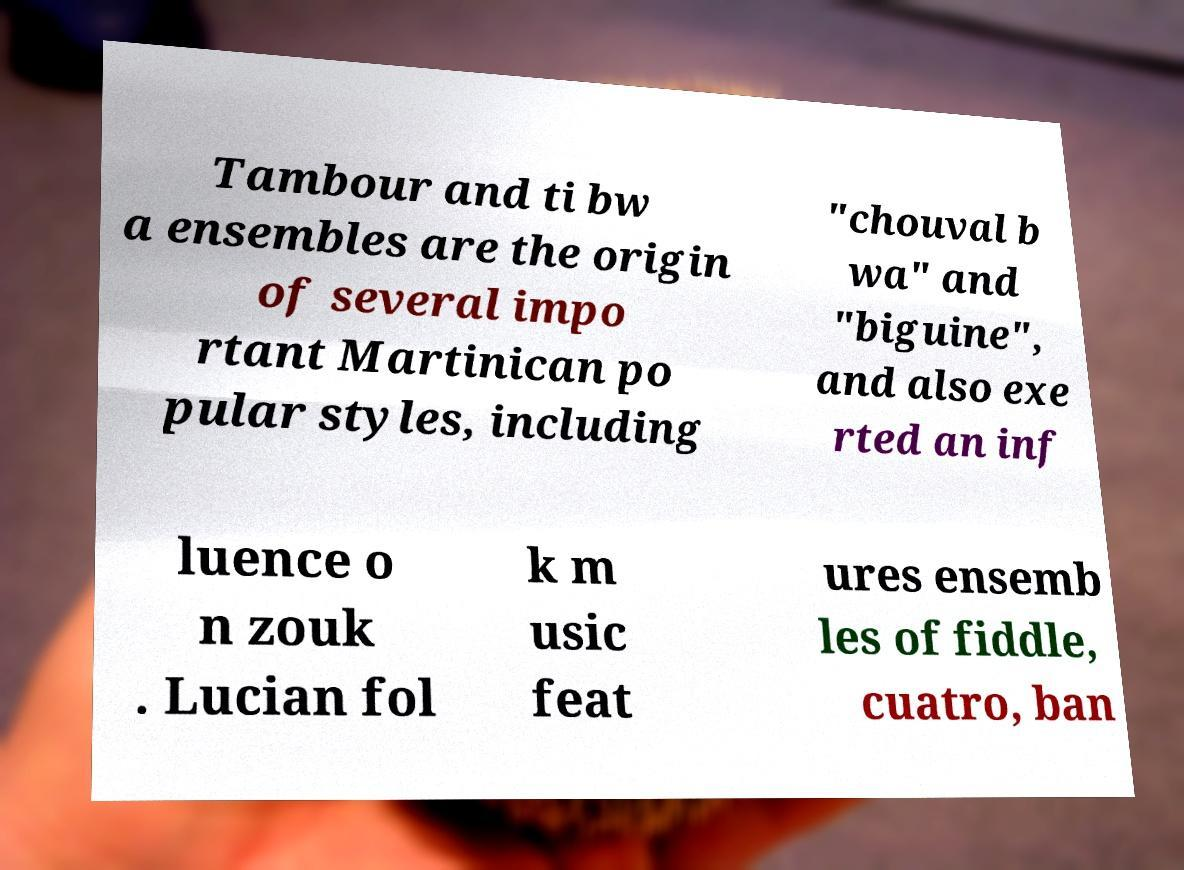Can you accurately transcribe the text from the provided image for me? Tambour and ti bw a ensembles are the origin of several impo rtant Martinican po pular styles, including "chouval b wa" and "biguine", and also exe rted an inf luence o n zouk . Lucian fol k m usic feat ures ensemb les of fiddle, cuatro, ban 